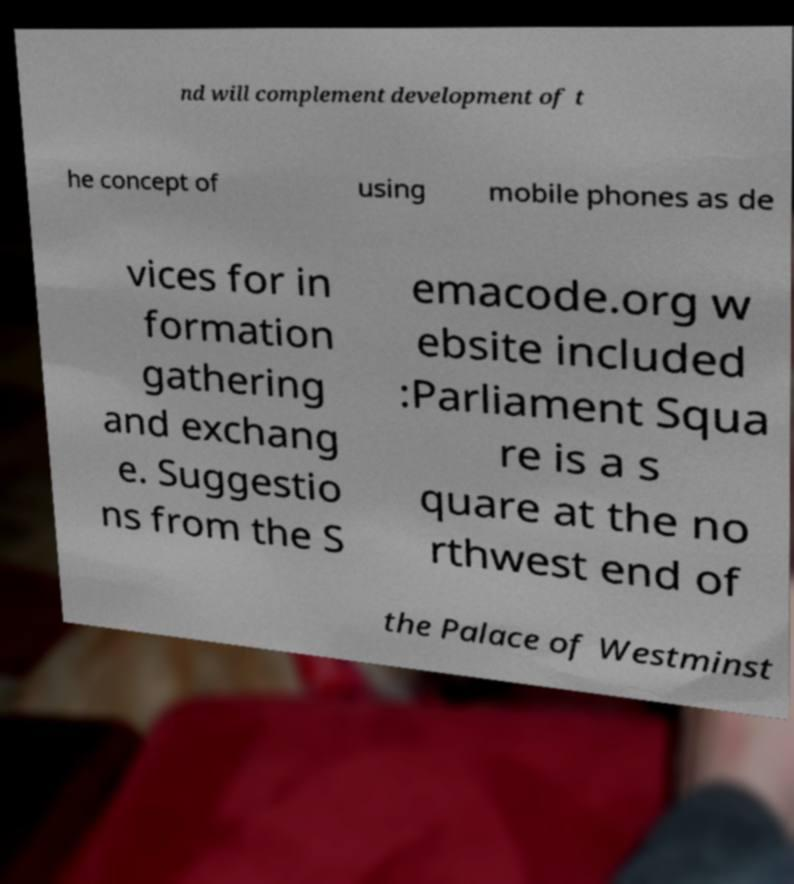What messages or text are displayed in this image? I need them in a readable, typed format. nd will complement development of t he concept of using mobile phones as de vices for in formation gathering and exchang e. Suggestio ns from the S emacode.org w ebsite included :Parliament Squa re is a s quare at the no rthwest end of the Palace of Westminst 